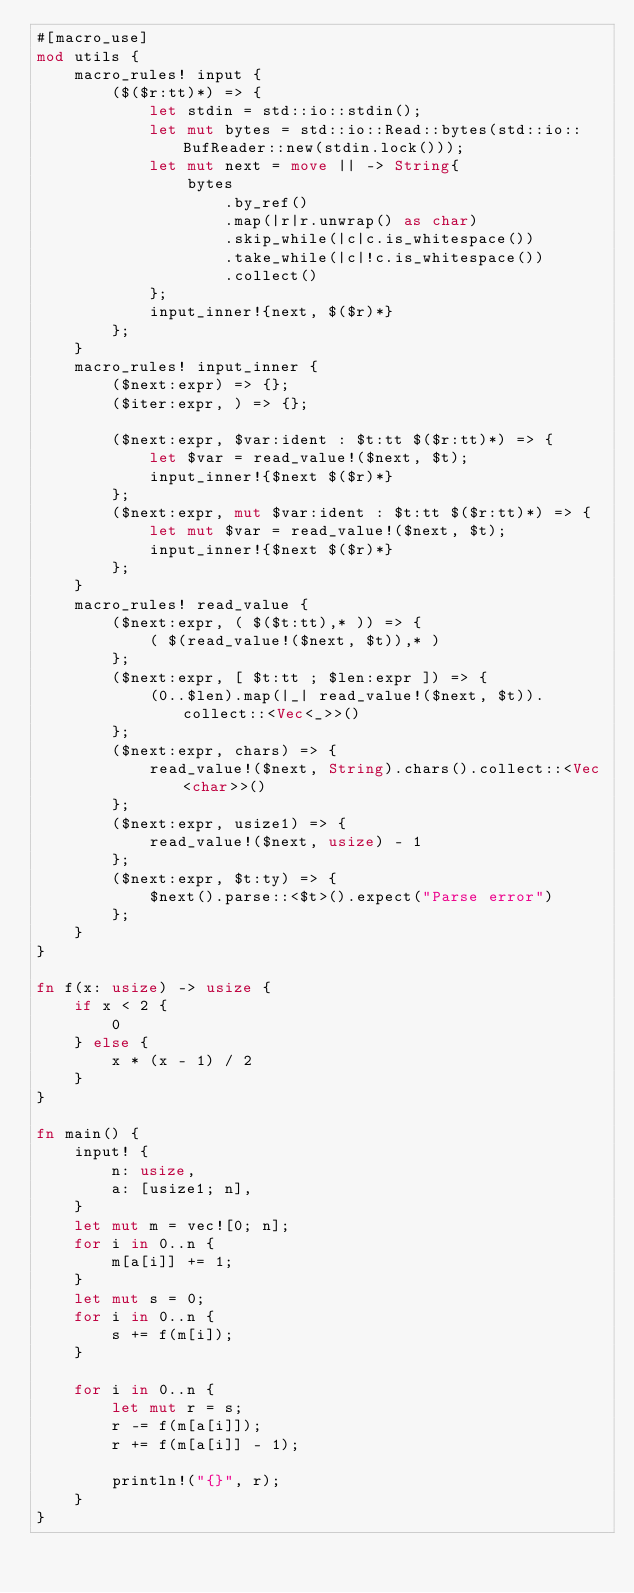<code> <loc_0><loc_0><loc_500><loc_500><_Rust_>#[macro_use]
mod utils {
    macro_rules! input {
        ($($r:tt)*) => {
            let stdin = std::io::stdin();
            let mut bytes = std::io::Read::bytes(std::io::BufReader::new(stdin.lock()));
            let mut next = move || -> String{
                bytes
                    .by_ref()
                    .map(|r|r.unwrap() as char)
                    .skip_while(|c|c.is_whitespace())
                    .take_while(|c|!c.is_whitespace())
                    .collect()
            };
            input_inner!{next, $($r)*}
        };
    }
    macro_rules! input_inner {
        ($next:expr) => {};
        ($iter:expr, ) => {};

        ($next:expr, $var:ident : $t:tt $($r:tt)*) => {
            let $var = read_value!($next, $t);
            input_inner!{$next $($r)*}
        };
        ($next:expr, mut $var:ident : $t:tt $($r:tt)*) => {
            let mut $var = read_value!($next, $t);
            input_inner!{$next $($r)*}
        };
    }
    macro_rules! read_value {
        ($next:expr, ( $($t:tt),* )) => {
            ( $(read_value!($next, $t)),* )
        };
        ($next:expr, [ $t:tt ; $len:expr ]) => {
            (0..$len).map(|_| read_value!($next, $t)).collect::<Vec<_>>()
        };
        ($next:expr, chars) => {
            read_value!($next, String).chars().collect::<Vec<char>>()
        };
        ($next:expr, usize1) => {
            read_value!($next, usize) - 1
        };
        ($next:expr, $t:ty) => {
            $next().parse::<$t>().expect("Parse error")
        };
    }
}

fn f(x: usize) -> usize {
    if x < 2 {
        0
    } else {
        x * (x - 1) / 2
    }
}

fn main() {
    input! {
        n: usize,
        a: [usize1; n],
    }
    let mut m = vec![0; n];
    for i in 0..n {
        m[a[i]] += 1;
    }
    let mut s = 0;
    for i in 0..n {
        s += f(m[i]);
    }

    for i in 0..n {
        let mut r = s;
        r -= f(m[a[i]]);
        r += f(m[a[i]] - 1);

        println!("{}", r);
    }
}
</code> 